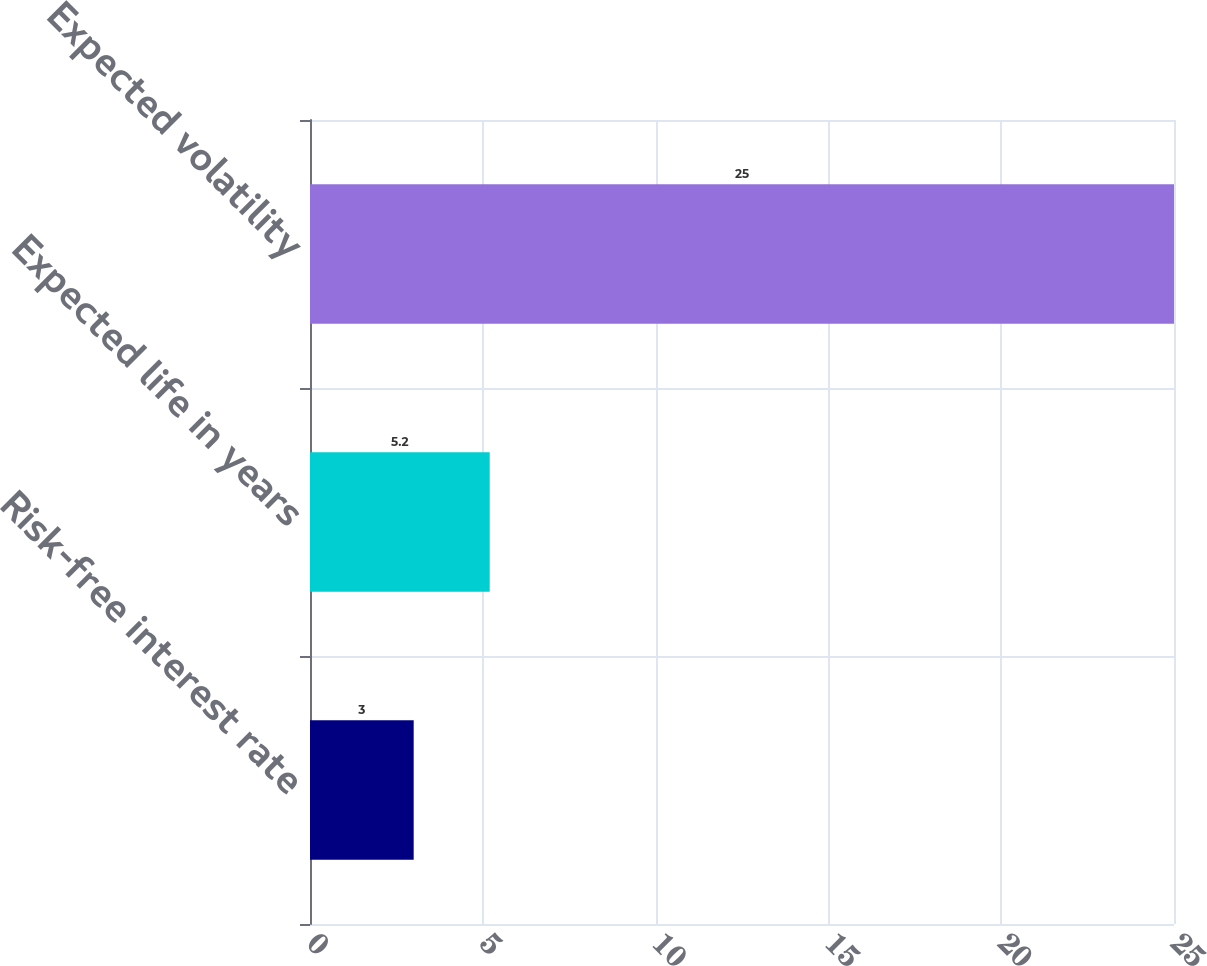<chart> <loc_0><loc_0><loc_500><loc_500><bar_chart><fcel>Risk-free interest rate<fcel>Expected life in years<fcel>Expected volatility<nl><fcel>3<fcel>5.2<fcel>25<nl></chart> 